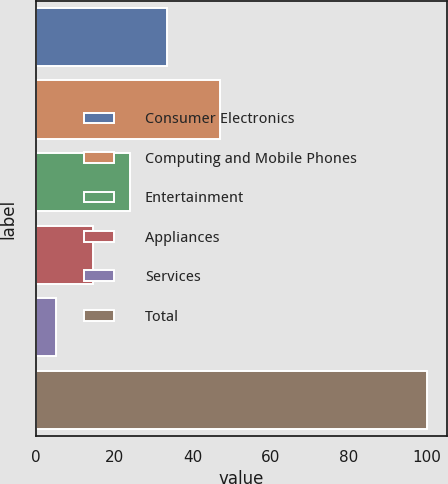<chart> <loc_0><loc_0><loc_500><loc_500><bar_chart><fcel>Consumer Electronics<fcel>Computing and Mobile Phones<fcel>Entertainment<fcel>Appliances<fcel>Services<fcel>Total<nl><fcel>33.5<fcel>47<fcel>24<fcel>14.5<fcel>5<fcel>100<nl></chart> 